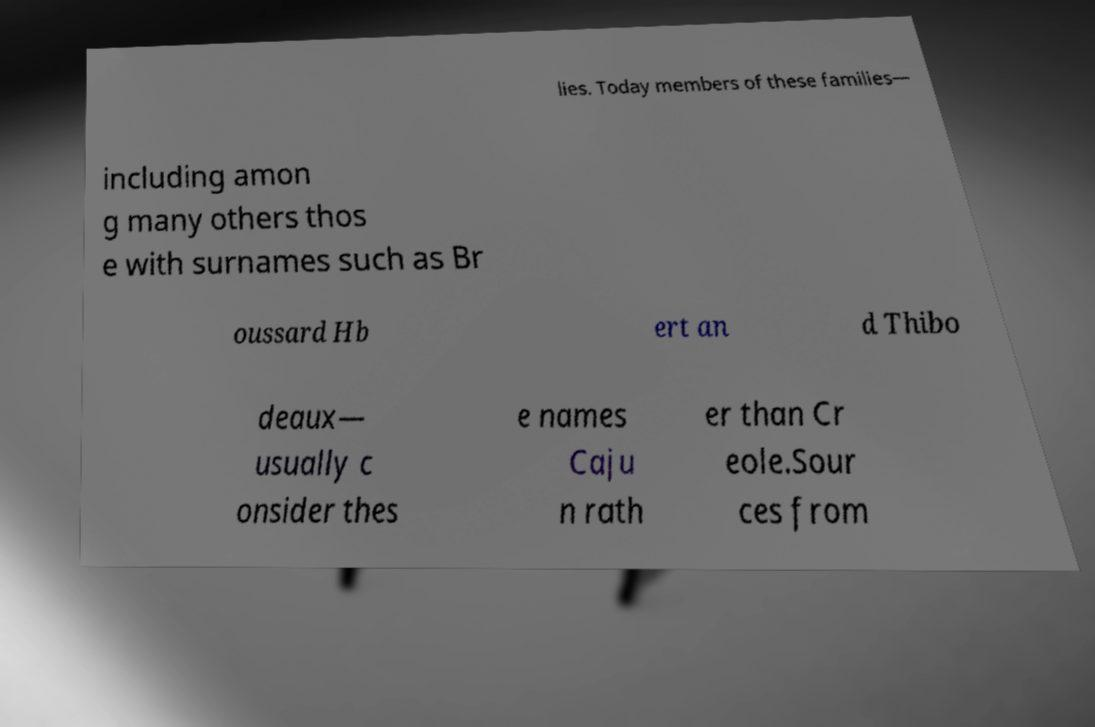Can you read and provide the text displayed in the image?This photo seems to have some interesting text. Can you extract and type it out for me? lies. Today members of these families— including amon g many others thos e with surnames such as Br oussard Hb ert an d Thibo deaux— usually c onsider thes e names Caju n rath er than Cr eole.Sour ces from 